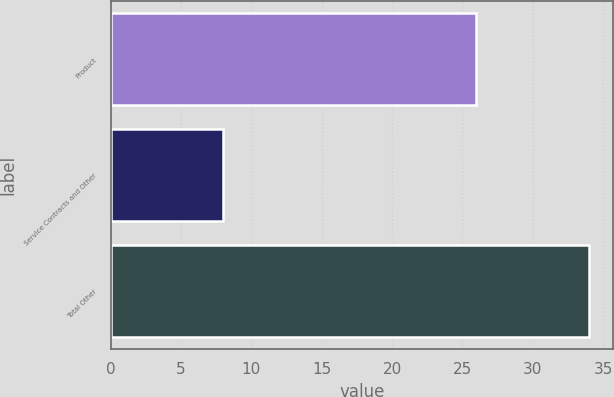<chart> <loc_0><loc_0><loc_500><loc_500><bar_chart><fcel>Product<fcel>Service Contracts and Other<fcel>Total Other<nl><fcel>26<fcel>8<fcel>34<nl></chart> 